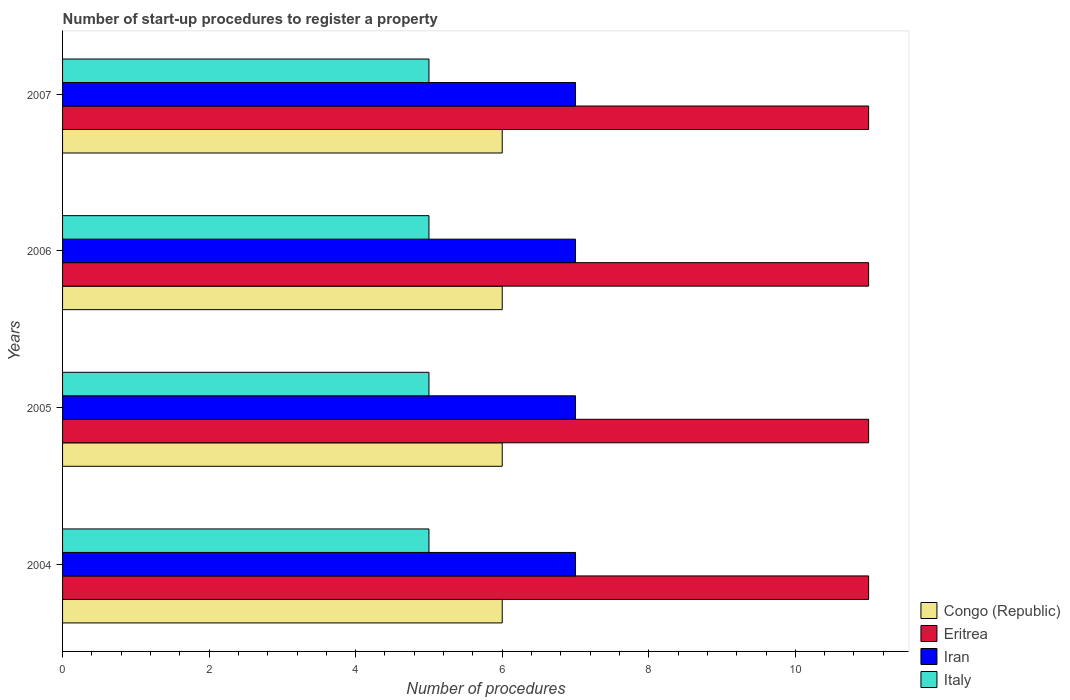Are the number of bars per tick equal to the number of legend labels?
Keep it short and to the point. Yes. Are the number of bars on each tick of the Y-axis equal?
Make the answer very short. Yes. How many bars are there on the 4th tick from the bottom?
Your response must be concise. 4. In how many cases, is the number of bars for a given year not equal to the number of legend labels?
Make the answer very short. 0. What is the number of procedures required to register a property in Congo (Republic) in 2004?
Keep it short and to the point. 6. Across all years, what is the maximum number of procedures required to register a property in Italy?
Your answer should be very brief. 5. Across all years, what is the minimum number of procedures required to register a property in Eritrea?
Ensure brevity in your answer.  11. In which year was the number of procedures required to register a property in Congo (Republic) maximum?
Provide a short and direct response. 2004. What is the total number of procedures required to register a property in Iran in the graph?
Make the answer very short. 28. What is the difference between the number of procedures required to register a property in Congo (Republic) in 2005 and that in 2006?
Make the answer very short. 0. What is the difference between the number of procedures required to register a property in Congo (Republic) in 2004 and the number of procedures required to register a property in Italy in 2005?
Give a very brief answer. 1. What is the average number of procedures required to register a property in Iran per year?
Ensure brevity in your answer.  7. In the year 2007, what is the difference between the number of procedures required to register a property in Italy and number of procedures required to register a property in Eritrea?
Provide a short and direct response. -6. Is the number of procedures required to register a property in Iran in 2004 less than that in 2007?
Offer a very short reply. No. Is the difference between the number of procedures required to register a property in Italy in 2005 and 2007 greater than the difference between the number of procedures required to register a property in Eritrea in 2005 and 2007?
Offer a very short reply. No. What is the difference between the highest and the second highest number of procedures required to register a property in Italy?
Your answer should be compact. 0. In how many years, is the number of procedures required to register a property in Congo (Republic) greater than the average number of procedures required to register a property in Congo (Republic) taken over all years?
Offer a very short reply. 0. What does the 3rd bar from the top in 2005 represents?
Keep it short and to the point. Eritrea. What does the 3rd bar from the bottom in 2006 represents?
Provide a succinct answer. Iran. Is it the case that in every year, the sum of the number of procedures required to register a property in Congo (Republic) and number of procedures required to register a property in Italy is greater than the number of procedures required to register a property in Iran?
Your answer should be very brief. Yes. How many years are there in the graph?
Offer a terse response. 4. Where does the legend appear in the graph?
Keep it short and to the point. Bottom right. How many legend labels are there?
Your answer should be very brief. 4. How are the legend labels stacked?
Give a very brief answer. Vertical. What is the title of the graph?
Your answer should be compact. Number of start-up procedures to register a property. Does "Canada" appear as one of the legend labels in the graph?
Give a very brief answer. No. What is the label or title of the X-axis?
Give a very brief answer. Number of procedures. What is the label or title of the Y-axis?
Provide a short and direct response. Years. What is the Number of procedures in Congo (Republic) in 2004?
Your answer should be compact. 6. What is the Number of procedures in Eritrea in 2004?
Offer a very short reply. 11. What is the Number of procedures of Italy in 2004?
Give a very brief answer. 5. What is the Number of procedures of Congo (Republic) in 2006?
Keep it short and to the point. 6. What is the Number of procedures of Iran in 2006?
Offer a very short reply. 7. What is the Number of procedures of Italy in 2006?
Give a very brief answer. 5. What is the Number of procedures of Iran in 2007?
Your response must be concise. 7. Across all years, what is the maximum Number of procedures in Congo (Republic)?
Your answer should be very brief. 6. Across all years, what is the maximum Number of procedures of Iran?
Your answer should be very brief. 7. Across all years, what is the minimum Number of procedures of Congo (Republic)?
Offer a terse response. 6. Across all years, what is the minimum Number of procedures in Eritrea?
Ensure brevity in your answer.  11. Across all years, what is the minimum Number of procedures of Iran?
Make the answer very short. 7. What is the total Number of procedures of Italy in the graph?
Provide a short and direct response. 20. What is the difference between the Number of procedures in Eritrea in 2004 and that in 2005?
Offer a terse response. 0. What is the difference between the Number of procedures in Congo (Republic) in 2004 and that in 2006?
Your response must be concise. 0. What is the difference between the Number of procedures of Iran in 2004 and that in 2006?
Offer a very short reply. 0. What is the difference between the Number of procedures of Italy in 2004 and that in 2006?
Give a very brief answer. 0. What is the difference between the Number of procedures of Eritrea in 2004 and that in 2007?
Offer a terse response. 0. What is the difference between the Number of procedures in Iran in 2004 and that in 2007?
Your answer should be very brief. 0. What is the difference between the Number of procedures of Congo (Republic) in 2005 and that in 2006?
Offer a very short reply. 0. What is the difference between the Number of procedures in Eritrea in 2005 and that in 2006?
Make the answer very short. 0. What is the difference between the Number of procedures in Eritrea in 2005 and that in 2007?
Your answer should be very brief. 0. What is the difference between the Number of procedures of Eritrea in 2006 and that in 2007?
Provide a succinct answer. 0. What is the difference between the Number of procedures of Iran in 2006 and that in 2007?
Offer a terse response. 0. What is the difference between the Number of procedures of Congo (Republic) in 2004 and the Number of procedures of Italy in 2005?
Your answer should be very brief. 1. What is the difference between the Number of procedures of Eritrea in 2004 and the Number of procedures of Iran in 2005?
Provide a succinct answer. 4. What is the difference between the Number of procedures in Eritrea in 2004 and the Number of procedures in Italy in 2005?
Provide a short and direct response. 6. What is the difference between the Number of procedures in Iran in 2004 and the Number of procedures in Italy in 2005?
Ensure brevity in your answer.  2. What is the difference between the Number of procedures of Congo (Republic) in 2004 and the Number of procedures of Iran in 2006?
Provide a short and direct response. -1. What is the difference between the Number of procedures of Eritrea in 2004 and the Number of procedures of Iran in 2006?
Keep it short and to the point. 4. What is the difference between the Number of procedures in Iran in 2004 and the Number of procedures in Italy in 2006?
Your answer should be compact. 2. What is the difference between the Number of procedures of Congo (Republic) in 2004 and the Number of procedures of Eritrea in 2007?
Provide a short and direct response. -5. What is the difference between the Number of procedures in Congo (Republic) in 2004 and the Number of procedures in Iran in 2007?
Offer a terse response. -1. What is the difference between the Number of procedures in Eritrea in 2004 and the Number of procedures in Iran in 2007?
Give a very brief answer. 4. What is the difference between the Number of procedures of Iran in 2004 and the Number of procedures of Italy in 2007?
Your answer should be compact. 2. What is the difference between the Number of procedures of Iran in 2005 and the Number of procedures of Italy in 2006?
Your answer should be very brief. 2. What is the difference between the Number of procedures in Congo (Republic) in 2005 and the Number of procedures in Eritrea in 2007?
Give a very brief answer. -5. What is the difference between the Number of procedures in Congo (Republic) in 2005 and the Number of procedures in Iran in 2007?
Keep it short and to the point. -1. What is the difference between the Number of procedures in Eritrea in 2005 and the Number of procedures in Italy in 2007?
Give a very brief answer. 6. What is the difference between the Number of procedures of Congo (Republic) in 2006 and the Number of procedures of Eritrea in 2007?
Your response must be concise. -5. What is the difference between the Number of procedures of Congo (Republic) in 2006 and the Number of procedures of Iran in 2007?
Offer a very short reply. -1. What is the difference between the Number of procedures in Congo (Republic) in 2006 and the Number of procedures in Italy in 2007?
Keep it short and to the point. 1. What is the difference between the Number of procedures of Eritrea in 2006 and the Number of procedures of Italy in 2007?
Your answer should be compact. 6. What is the difference between the Number of procedures of Iran in 2006 and the Number of procedures of Italy in 2007?
Ensure brevity in your answer.  2. In the year 2004, what is the difference between the Number of procedures of Congo (Republic) and Number of procedures of Eritrea?
Offer a very short reply. -5. In the year 2004, what is the difference between the Number of procedures in Congo (Republic) and Number of procedures in Iran?
Offer a very short reply. -1. In the year 2004, what is the difference between the Number of procedures of Iran and Number of procedures of Italy?
Provide a succinct answer. 2. In the year 2005, what is the difference between the Number of procedures in Congo (Republic) and Number of procedures in Italy?
Your response must be concise. 1. In the year 2005, what is the difference between the Number of procedures in Eritrea and Number of procedures in Iran?
Your answer should be compact. 4. In the year 2006, what is the difference between the Number of procedures of Eritrea and Number of procedures of Iran?
Your answer should be very brief. 4. In the year 2006, what is the difference between the Number of procedures of Eritrea and Number of procedures of Italy?
Provide a short and direct response. 6. In the year 2007, what is the difference between the Number of procedures in Congo (Republic) and Number of procedures in Eritrea?
Keep it short and to the point. -5. In the year 2007, what is the difference between the Number of procedures in Congo (Republic) and Number of procedures in Iran?
Your response must be concise. -1. In the year 2007, what is the difference between the Number of procedures of Congo (Republic) and Number of procedures of Italy?
Offer a terse response. 1. What is the ratio of the Number of procedures of Congo (Republic) in 2004 to that in 2005?
Give a very brief answer. 1. What is the ratio of the Number of procedures in Eritrea in 2004 to that in 2005?
Your answer should be very brief. 1. What is the ratio of the Number of procedures in Iran in 2004 to that in 2005?
Your answer should be compact. 1. What is the ratio of the Number of procedures of Italy in 2004 to that in 2005?
Give a very brief answer. 1. What is the ratio of the Number of procedures of Congo (Republic) in 2004 to that in 2006?
Keep it short and to the point. 1. What is the ratio of the Number of procedures in Eritrea in 2004 to that in 2006?
Your answer should be compact. 1. What is the ratio of the Number of procedures of Iran in 2004 to that in 2006?
Your answer should be compact. 1. What is the ratio of the Number of procedures in Italy in 2004 to that in 2006?
Offer a terse response. 1. What is the ratio of the Number of procedures of Iran in 2004 to that in 2007?
Your answer should be very brief. 1. What is the ratio of the Number of procedures in Italy in 2004 to that in 2007?
Provide a short and direct response. 1. What is the ratio of the Number of procedures in Eritrea in 2005 to that in 2006?
Provide a short and direct response. 1. What is the ratio of the Number of procedures in Italy in 2005 to that in 2006?
Ensure brevity in your answer.  1. What is the ratio of the Number of procedures of Congo (Republic) in 2005 to that in 2007?
Offer a terse response. 1. What is the ratio of the Number of procedures in Eritrea in 2005 to that in 2007?
Give a very brief answer. 1. What is the ratio of the Number of procedures of Congo (Republic) in 2006 to that in 2007?
Your answer should be compact. 1. What is the ratio of the Number of procedures of Eritrea in 2006 to that in 2007?
Offer a terse response. 1. What is the ratio of the Number of procedures of Italy in 2006 to that in 2007?
Provide a succinct answer. 1. What is the difference between the highest and the second highest Number of procedures of Congo (Republic)?
Keep it short and to the point. 0. What is the difference between the highest and the second highest Number of procedures of Eritrea?
Your answer should be compact. 0. What is the difference between the highest and the second highest Number of procedures of Iran?
Keep it short and to the point. 0. What is the difference between the highest and the second highest Number of procedures of Italy?
Your answer should be compact. 0. What is the difference between the highest and the lowest Number of procedures in Congo (Republic)?
Offer a terse response. 0. What is the difference between the highest and the lowest Number of procedures in Eritrea?
Make the answer very short. 0. 